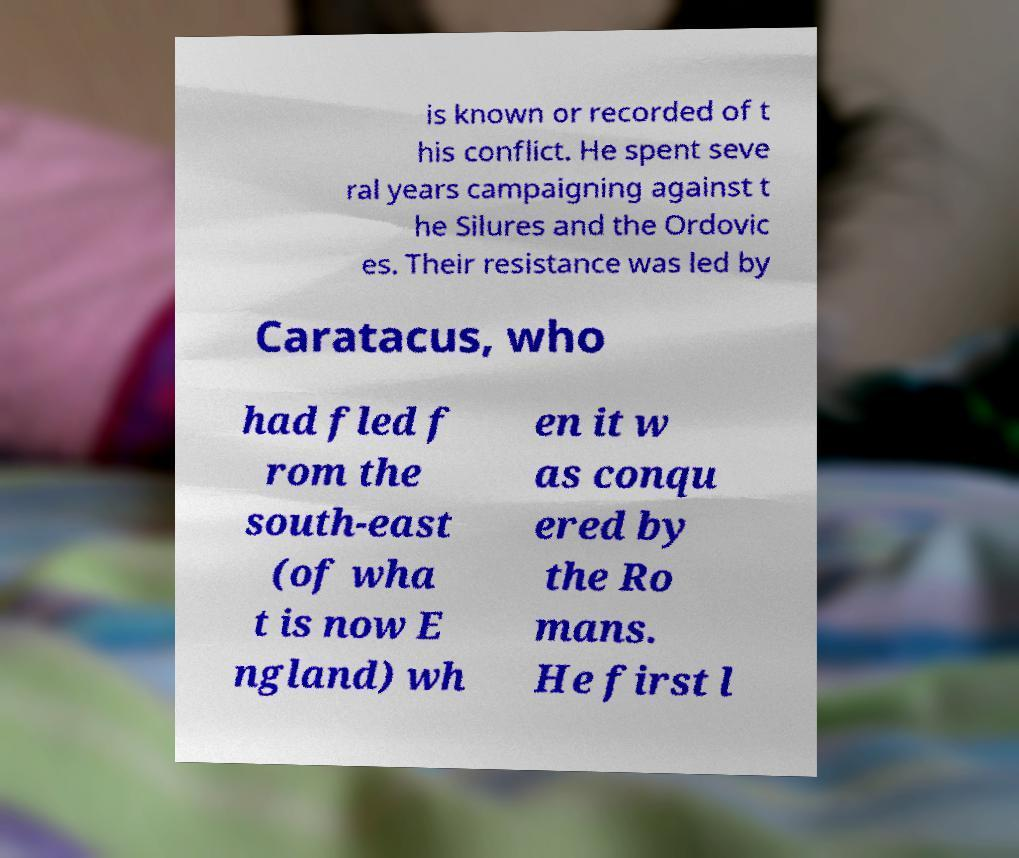Can you accurately transcribe the text from the provided image for me? is known or recorded of t his conflict. He spent seve ral years campaigning against t he Silures and the Ordovic es. Their resistance was led by Caratacus, who had fled f rom the south-east (of wha t is now E ngland) wh en it w as conqu ered by the Ro mans. He first l 